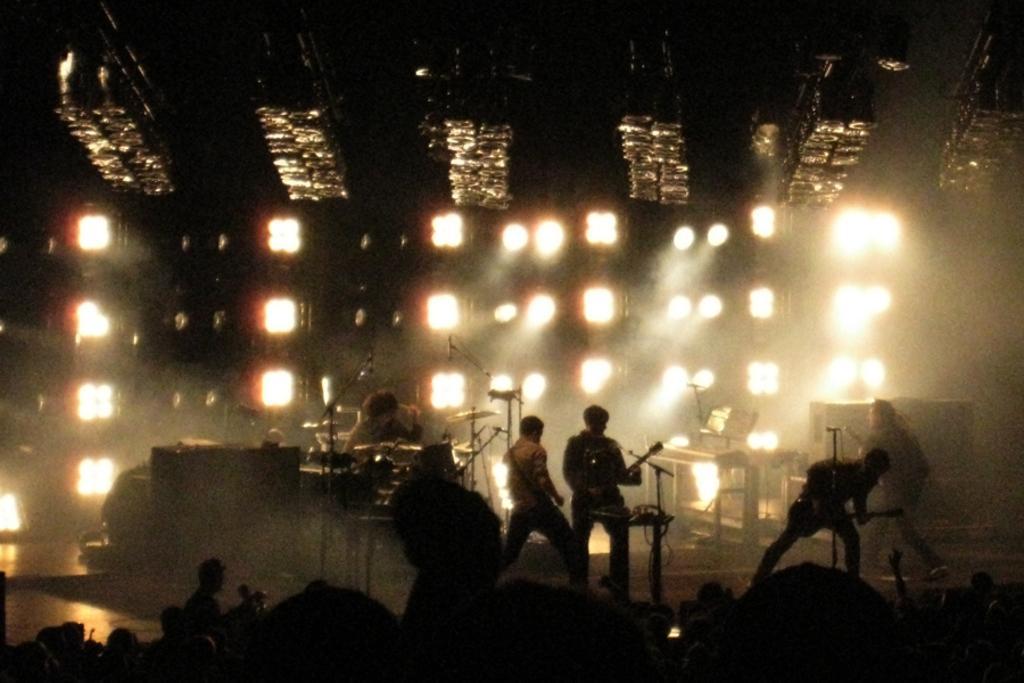How would you summarize this image in a sentence or two? In this picture we can see a group of people and some people are standing on the stage. On the stage there are stands, some musical instruments and other objects. Behind the people there are lights. At the top, those are looking like trusses. 